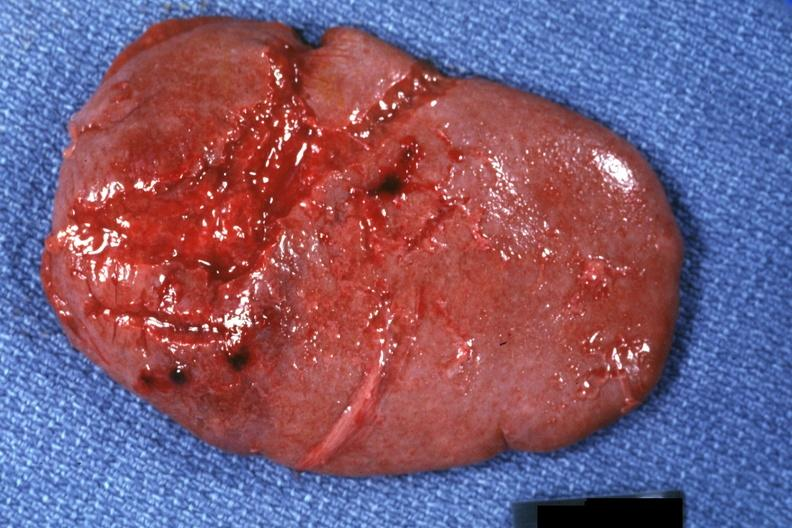what is present?
Answer the question using a single word or phrase. Hematologic 